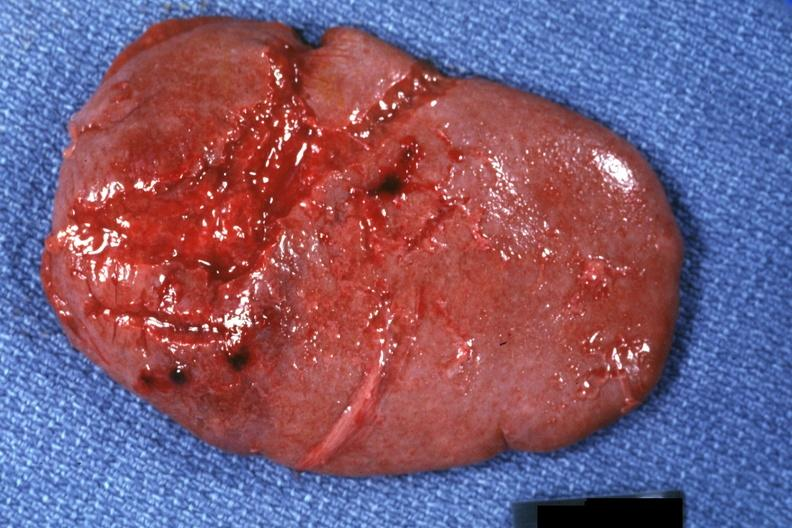what is present?
Answer the question using a single word or phrase. Hematologic 